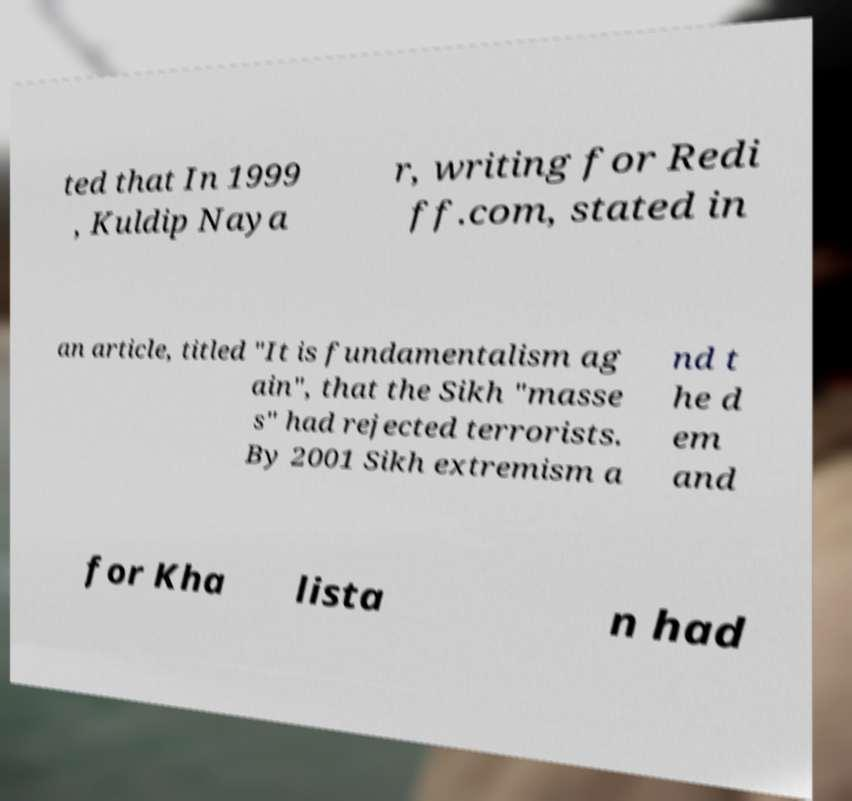Could you assist in decoding the text presented in this image and type it out clearly? ted that In 1999 , Kuldip Naya r, writing for Redi ff.com, stated in an article, titled "It is fundamentalism ag ain", that the Sikh "masse s" had rejected terrorists. By 2001 Sikh extremism a nd t he d em and for Kha lista n had 